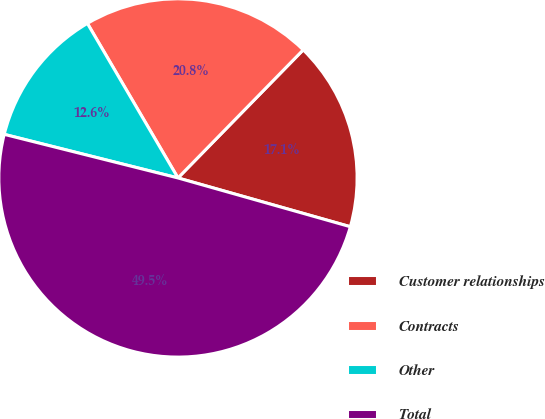<chart> <loc_0><loc_0><loc_500><loc_500><pie_chart><fcel>Customer relationships<fcel>Contracts<fcel>Other<fcel>Total<nl><fcel>17.07%<fcel>20.76%<fcel>12.65%<fcel>49.53%<nl></chart> 